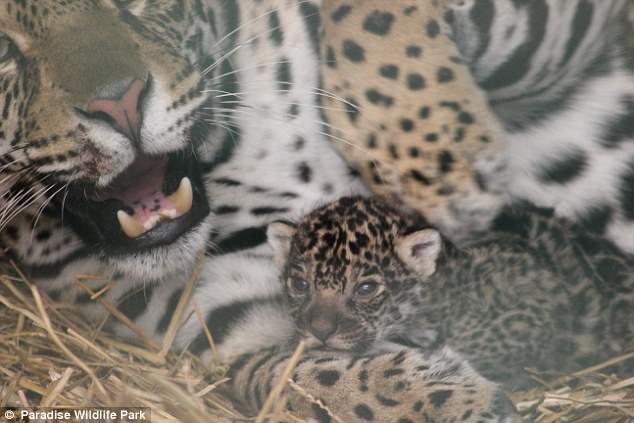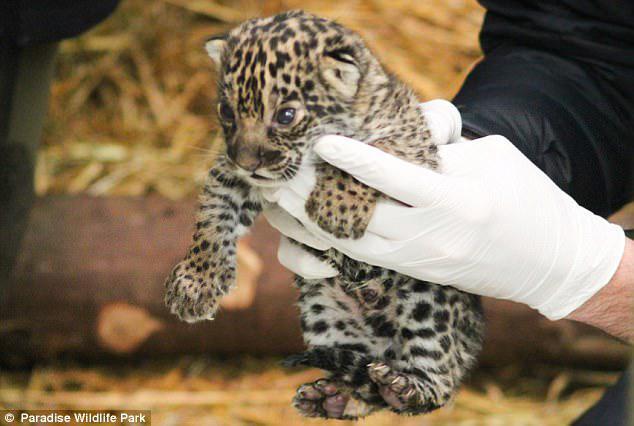The first image is the image on the left, the second image is the image on the right. Analyze the images presented: Is the assertion "Each image shows two leopards in an enclosure, and at least one image features an adult leopard with a young leopard kitten." valid? Answer yes or no. No. The first image is the image on the left, the second image is the image on the right. For the images shown, is this caption "Both images have straw bedding." true? Answer yes or no. Yes. 